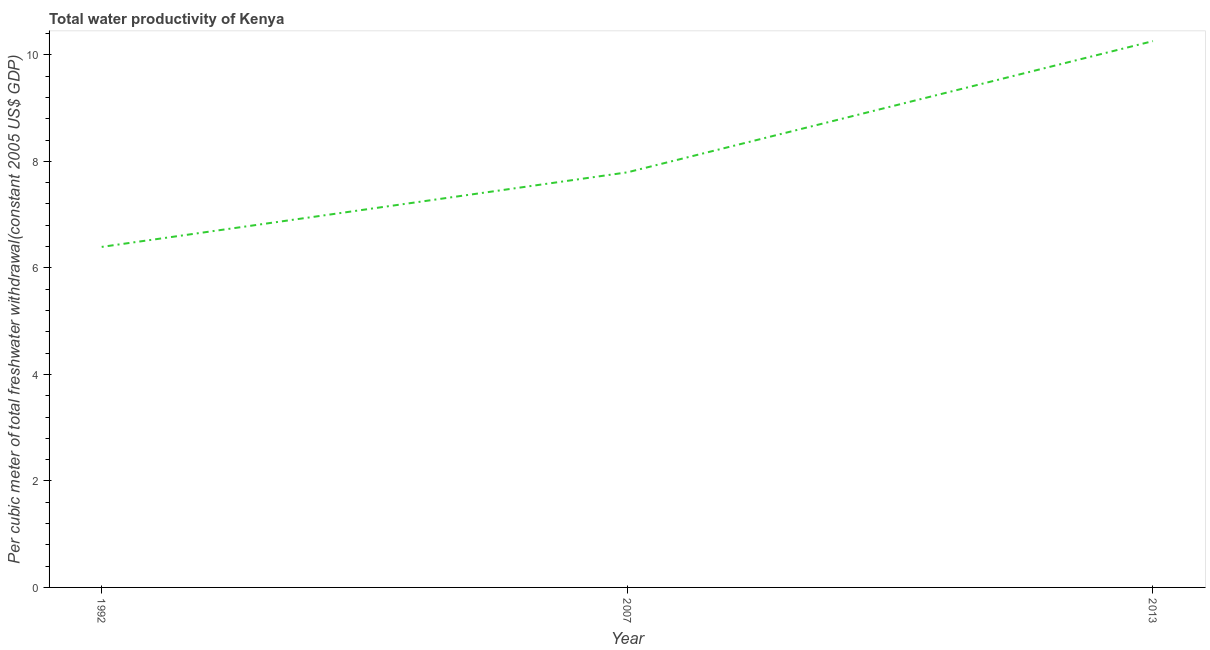What is the total water productivity in 1992?
Give a very brief answer. 6.39. Across all years, what is the maximum total water productivity?
Make the answer very short. 10.26. Across all years, what is the minimum total water productivity?
Your response must be concise. 6.39. In which year was the total water productivity minimum?
Keep it short and to the point. 1992. What is the sum of the total water productivity?
Keep it short and to the point. 24.45. What is the difference between the total water productivity in 1992 and 2013?
Give a very brief answer. -3.86. What is the average total water productivity per year?
Give a very brief answer. 8.15. What is the median total water productivity?
Your answer should be compact. 7.79. What is the ratio of the total water productivity in 1992 to that in 2007?
Your response must be concise. 0.82. Is the difference between the total water productivity in 1992 and 2007 greater than the difference between any two years?
Provide a succinct answer. No. What is the difference between the highest and the second highest total water productivity?
Your answer should be very brief. 2.46. Is the sum of the total water productivity in 1992 and 2007 greater than the maximum total water productivity across all years?
Make the answer very short. Yes. What is the difference between the highest and the lowest total water productivity?
Offer a terse response. 3.86. Does the total water productivity monotonically increase over the years?
Provide a succinct answer. Yes. How many lines are there?
Your response must be concise. 1. What is the title of the graph?
Your answer should be very brief. Total water productivity of Kenya. What is the label or title of the Y-axis?
Your answer should be very brief. Per cubic meter of total freshwater withdrawal(constant 2005 US$ GDP). What is the Per cubic meter of total freshwater withdrawal(constant 2005 US$ GDP) in 1992?
Offer a terse response. 6.39. What is the Per cubic meter of total freshwater withdrawal(constant 2005 US$ GDP) of 2007?
Ensure brevity in your answer.  7.79. What is the Per cubic meter of total freshwater withdrawal(constant 2005 US$ GDP) of 2013?
Keep it short and to the point. 10.26. What is the difference between the Per cubic meter of total freshwater withdrawal(constant 2005 US$ GDP) in 1992 and 2007?
Your response must be concise. -1.4. What is the difference between the Per cubic meter of total freshwater withdrawal(constant 2005 US$ GDP) in 1992 and 2013?
Keep it short and to the point. -3.86. What is the difference between the Per cubic meter of total freshwater withdrawal(constant 2005 US$ GDP) in 2007 and 2013?
Provide a succinct answer. -2.46. What is the ratio of the Per cubic meter of total freshwater withdrawal(constant 2005 US$ GDP) in 1992 to that in 2007?
Give a very brief answer. 0.82. What is the ratio of the Per cubic meter of total freshwater withdrawal(constant 2005 US$ GDP) in 1992 to that in 2013?
Offer a very short reply. 0.62. What is the ratio of the Per cubic meter of total freshwater withdrawal(constant 2005 US$ GDP) in 2007 to that in 2013?
Keep it short and to the point. 0.76. 